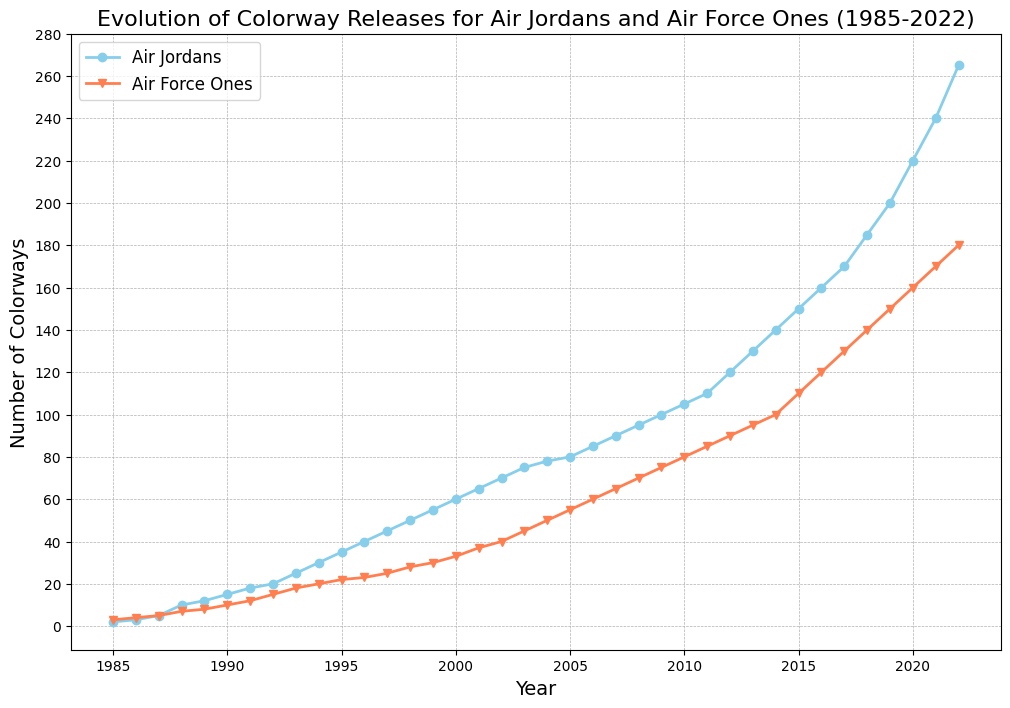What is the total number of Air Jordans colorways released during the period 1985 to 2022? To find the total, sum up the number of colorways released each year for Air Jordans from the data. This involves summing each yearly value from 1985 to 2022 for Air Jordans.
Answer: 2675 When was the first time the number of Air Force One colorways released exceeded 50 in a year? Reviewing the yearly data for Air Force Ones, the first year the number of colorways exceeded 50 was 2004. Check year-by-year counts until you find a value over 50.
Answer: 2004 By what percentage did the number of Air Jordans colorways released increase from 1990 to 1991? The number of Air Jordan colorways in 1990 was 15 and in 1991 it was 18. The percentage increase is calculated as ((18 - 15) / 15) * 100.
Answer: 20% Which year showed the greatest difference between Air Jordan and Air Force One colorways released? Calculate the yearly difference (Air Jordan - Air Force One) for each year. The year with the biggest difference is 2022, where the difference is highest (265 - 180 = 85).
Answer: 2022 How many more colorways of Air Jordans than Air Force Ones were there in 2015? Look at the data for 2015: Air Jordans = 150, Air Force Ones = 110. Subtract the Air Force Ones count from the Air Jordans count (150 - 110).
Answer: 40 Which line on the chart has the steeper increase between the years 2018 to 2020? Compare the slopes of the lines between these years. The Air Jordan line increases by 35 (185 to 220), and the Air Force One line increases by 20 (140 to 160). Thus, Air Jordan has a steeper increase.
Answer: Air Jordan In how many years did the Air Jordans release more colorways than Air Force Ones? Count the number of years where the Air Jordan line is above the Air Force One line. This comparison shows that for every year in the data, Air Jordans released more colorways.
Answer: 38 What is the average number of Air Jordan colorways released per year from 2000 to 2010? Sum the number of Air Jordan colorways released from 2000 to 2010 and then divide by the number of years (11). Sum = 2000(60) + 2001(65) + 2002(70) + 2003(75) + 2004(78) + 2005(80) + 2006(85) + 2007(90) + 2008(95) + 2009(100) + 2010(105) = 893. Divide by 11.
Answer: 81.2 Which year had the slowest growth rate for Air Force One colorways, assuming growth rate means the difference compared to the previous year? Look for the year with the smallest difference in the number of colorways released compared to the previous year for Air Force Ones. From the data, the smallest yearly increase is 1987-1988 (5 - 4) = 1.
Answer: 1987 